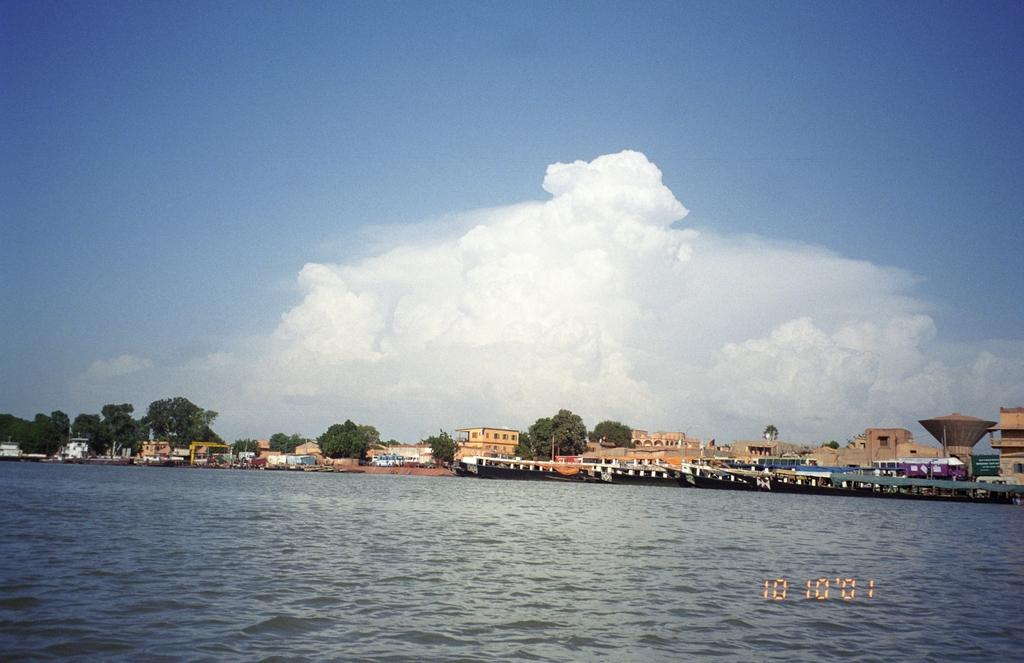What is on the water in the image? There are boats on the water in the image. What can be seen in the background of the image? There are trees and buildings in the background of the image. What color are the trees in the image? The trees are green in the image. What colors are the buildings in the image? The buildings are in cream and white colors in the image. What is the color of the sky in the image? The sky is blue and white in the image. Can you see a spy playing basketball with the trees in the image? There is no spy or basketball present in the image; it features boats on the water, trees, buildings, and a blue and white sky. 